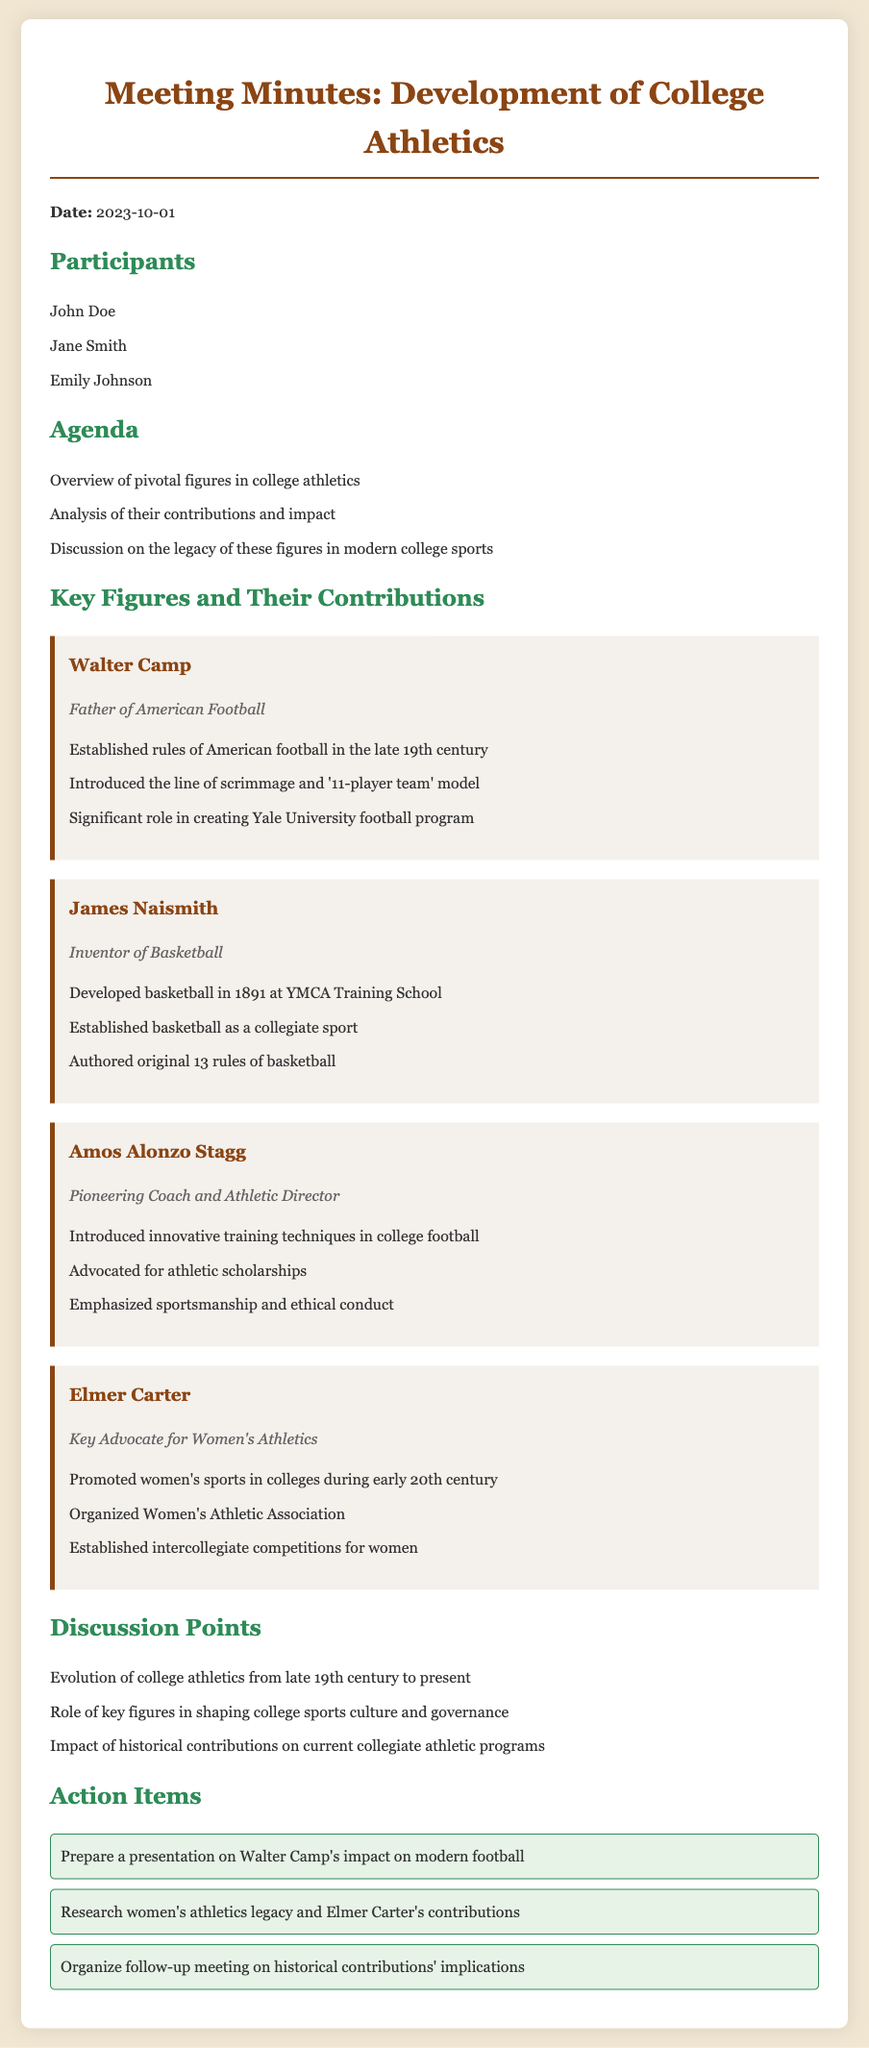What is the date of the meeting? The date is mentioned in the header of the document.
Answer: 2023-10-01 Who is referred to as the "Father of American Football"? This title is given in the section about Walter Camp.
Answer: Walter Camp What major sport did James Naismith invent? This information is provided in the description of James Naismith.
Answer: Basketball What organization did Elmer Carter establish for women? The document lists this achievement under Elmer Carter's contributions.
Answer: Women's Athletic Association What was one of Amos Alonzo Stagg's key contributions to college athletics? This can be found in the section describing Amos Alonzo Stagg's achievements.
Answer: Advocated for athletic scholarships What are the names of the three participants in the meeting? The names are listed in the Participants section of the document.
Answer: John Doe, Jane Smith, Emily Johnson Which key figure promoted women's sports in colleges? This is specified in the section dedicated to Elmer Carter.
Answer: Elmer Carter What is one action item discussed in the meeting? Action items are listed at the end of the document.
Answer: Prepare a presentation on Walter Camp's impact on modern football 